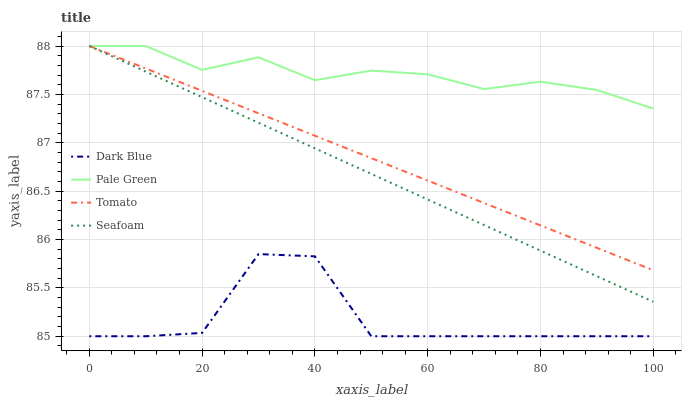Does Dark Blue have the minimum area under the curve?
Answer yes or no. Yes. Does Pale Green have the maximum area under the curve?
Answer yes or no. Yes. Does Pale Green have the minimum area under the curve?
Answer yes or no. No. Does Dark Blue have the maximum area under the curve?
Answer yes or no. No. Is Tomato the smoothest?
Answer yes or no. Yes. Is Dark Blue the roughest?
Answer yes or no. Yes. Is Pale Green the smoothest?
Answer yes or no. No. Is Pale Green the roughest?
Answer yes or no. No. Does Pale Green have the lowest value?
Answer yes or no. No. Does Seafoam have the highest value?
Answer yes or no. Yes. Does Dark Blue have the highest value?
Answer yes or no. No. Is Dark Blue less than Tomato?
Answer yes or no. Yes. Is Pale Green greater than Dark Blue?
Answer yes or no. Yes. Does Dark Blue intersect Tomato?
Answer yes or no. No. 